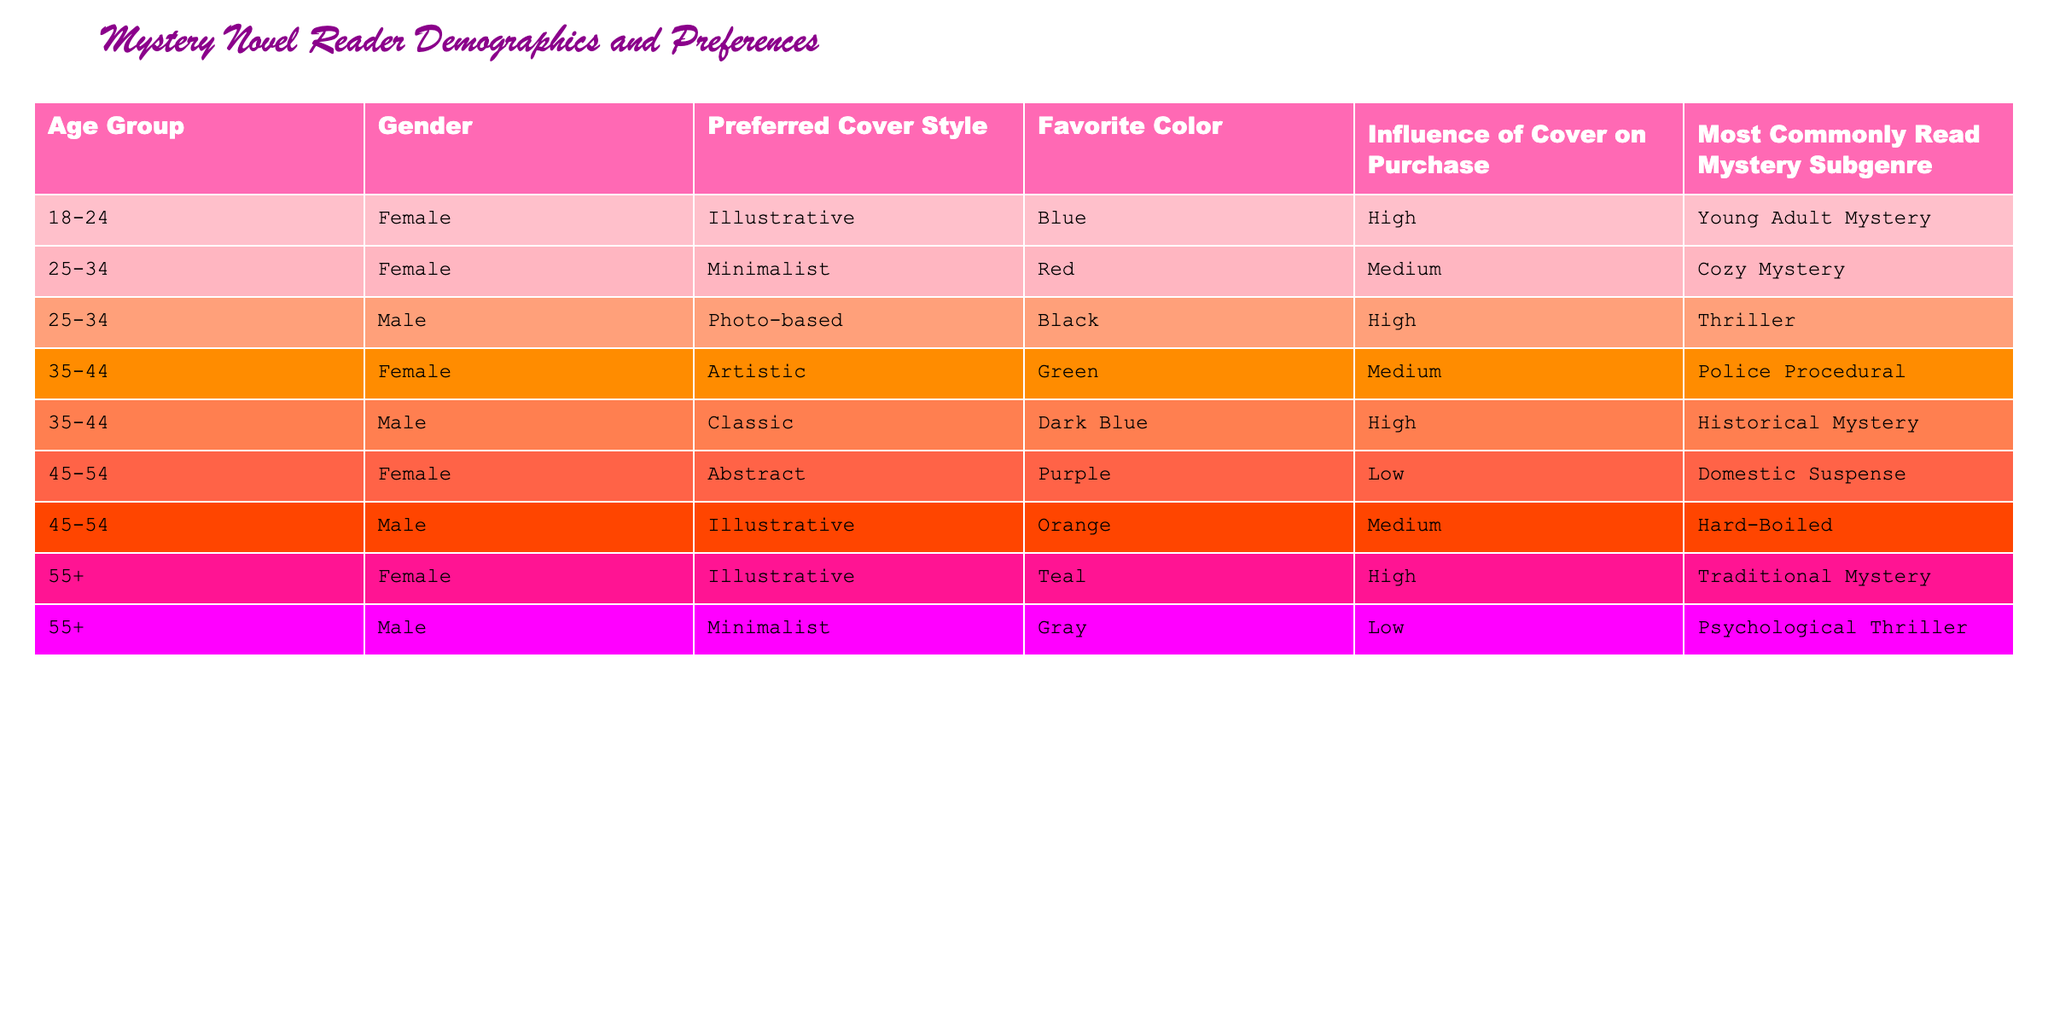What is the preferred cover style of readers aged 45-54? Looking at the row corresponding to the 45-54 age group, we see both a female and male category. The female prefers an Abstract style, while the male prefers an Illustrative style. The question asks specifically for the preferred cover style, so we can mention both.
Answer: Abstract and Illustrative Which gender predominantly prefers the Photo-based cover style? Checking the table, it shows that only one male reader prefers the Photo-based style, while there are no females listed for this style. Thus, the predominant gender for this style is male.
Answer: Male Are most readers influenced by the cover in their purchase decision? Looking at the 'Influence of Cover on Purchase' column, we identify the values High, Medium, and Low. The High and Medium categories indicate that most readers (4 out of 8) consider the cover influential for their purchase decision. Thus, the answer is yes.
Answer: Yes How many readers have a favorite color of blue? In the Favorite Color column, we find the color blue listed next to the preferences of both the 18-24 female reader and the 55+ female reader, totaling 2 occurrences. Therefore, 2 readers have blue as their favorite color.
Answer: 2 What is the most commonly read mystery subgenre for females in the 25-34 age group? In the 25-34 age group under the Female category, the table shows the subgenre listed as Cozy Mystery. Thus, we can directly answer the question with this data point.
Answer: Cozy Mystery What is the difference in the influence of the cover on purchases for Male readers between the 25-34 age group and the 35-44 age group? The influence for the 25-34 Male reader is High and for the 35-44 Male reader is also High. Since both values are the same, the difference here is 0.
Answer: 0 Which age group has the most diverse preferred cover styles? By checking the preferred cover styles across all age groups, we can see that the groups 25-34 and 35-44 each have three unique styles (Minimalist, Photo-based, Classic; and Artistic, Classic, respectively). However, the 45-54 age group has 2 different styles (Abstract, Illustrative). Thus, the age groups with the most varied styles are 25-34 and 35-44.
Answer: 25-34 and 35-44 Is there any overlap in favorite colors amongst readers in the same age group? Looking closely, the 45-54 age group shows an overlap where the male likes Orange and the female likes Purple, indicating no overlap. The other age groups also have individuals selecting different colors without any overlaps in their same age groups. Therefore, the overlap question concludes with no.
Answer: No 